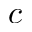<formula> <loc_0><loc_0><loc_500><loc_500>c</formula> 